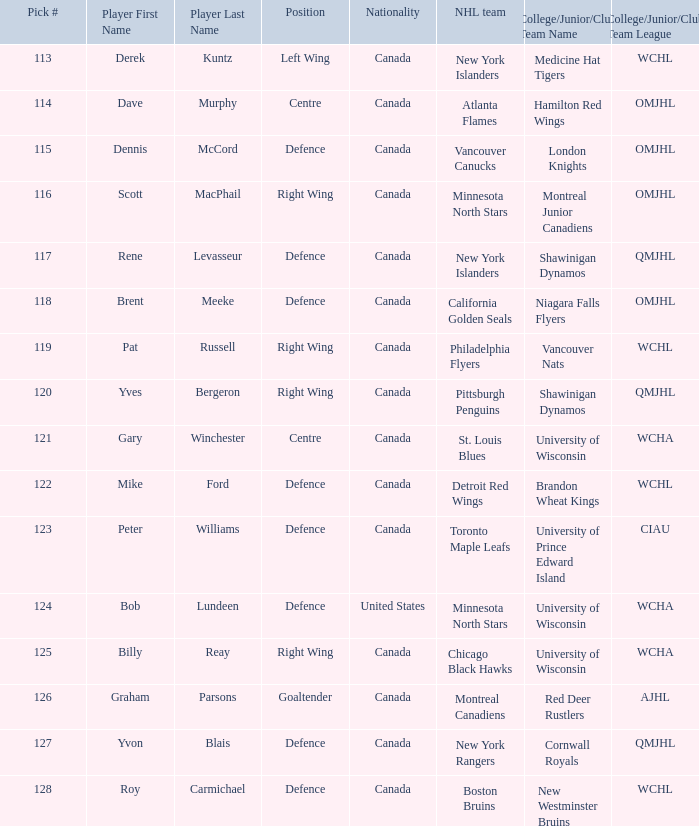Name the position for pick number 128 Defence. 